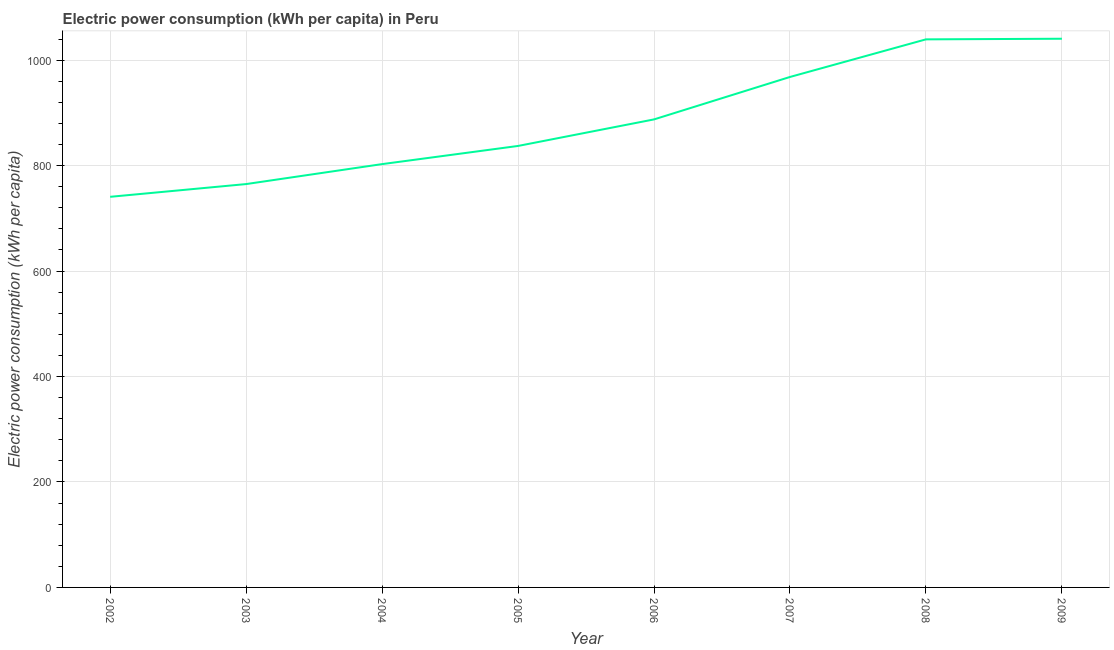What is the electric power consumption in 2005?
Your response must be concise. 837.29. Across all years, what is the maximum electric power consumption?
Your response must be concise. 1040.63. Across all years, what is the minimum electric power consumption?
Your answer should be very brief. 740.82. In which year was the electric power consumption minimum?
Your answer should be very brief. 2002. What is the sum of the electric power consumption?
Provide a succinct answer. 7081.78. What is the difference between the electric power consumption in 2003 and 2004?
Offer a very short reply. -37.85. What is the average electric power consumption per year?
Your answer should be very brief. 885.22. What is the median electric power consumption?
Provide a short and direct response. 862.46. In how many years, is the electric power consumption greater than 920 kWh per capita?
Provide a short and direct response. 3. What is the ratio of the electric power consumption in 2005 to that in 2006?
Your response must be concise. 0.94. Is the difference between the electric power consumption in 2003 and 2005 greater than the difference between any two years?
Offer a terse response. No. What is the difference between the highest and the second highest electric power consumption?
Provide a succinct answer. 1.18. What is the difference between the highest and the lowest electric power consumption?
Give a very brief answer. 299.81. Does the graph contain any zero values?
Give a very brief answer. No. What is the title of the graph?
Your answer should be very brief. Electric power consumption (kWh per capita) in Peru. What is the label or title of the X-axis?
Your response must be concise. Year. What is the label or title of the Y-axis?
Provide a succinct answer. Electric power consumption (kWh per capita). What is the Electric power consumption (kWh per capita) of 2002?
Ensure brevity in your answer.  740.82. What is the Electric power consumption (kWh per capita) in 2003?
Keep it short and to the point. 764.99. What is the Electric power consumption (kWh per capita) in 2004?
Ensure brevity in your answer.  802.84. What is the Electric power consumption (kWh per capita) in 2005?
Your answer should be compact. 837.29. What is the Electric power consumption (kWh per capita) of 2006?
Keep it short and to the point. 887.62. What is the Electric power consumption (kWh per capita) in 2007?
Provide a short and direct response. 968.13. What is the Electric power consumption (kWh per capita) of 2008?
Your answer should be compact. 1039.45. What is the Electric power consumption (kWh per capita) of 2009?
Offer a terse response. 1040.63. What is the difference between the Electric power consumption (kWh per capita) in 2002 and 2003?
Your response must be concise. -24.16. What is the difference between the Electric power consumption (kWh per capita) in 2002 and 2004?
Your answer should be compact. -62.02. What is the difference between the Electric power consumption (kWh per capita) in 2002 and 2005?
Ensure brevity in your answer.  -96.47. What is the difference between the Electric power consumption (kWh per capita) in 2002 and 2006?
Make the answer very short. -146.8. What is the difference between the Electric power consumption (kWh per capita) in 2002 and 2007?
Offer a very short reply. -227.3. What is the difference between the Electric power consumption (kWh per capita) in 2002 and 2008?
Ensure brevity in your answer.  -298.63. What is the difference between the Electric power consumption (kWh per capita) in 2002 and 2009?
Give a very brief answer. -299.81. What is the difference between the Electric power consumption (kWh per capita) in 2003 and 2004?
Your response must be concise. -37.85. What is the difference between the Electric power consumption (kWh per capita) in 2003 and 2005?
Keep it short and to the point. -72.31. What is the difference between the Electric power consumption (kWh per capita) in 2003 and 2006?
Your response must be concise. -122.64. What is the difference between the Electric power consumption (kWh per capita) in 2003 and 2007?
Provide a short and direct response. -203.14. What is the difference between the Electric power consumption (kWh per capita) in 2003 and 2008?
Provide a short and direct response. -274.46. What is the difference between the Electric power consumption (kWh per capita) in 2003 and 2009?
Provide a succinct answer. -275.65. What is the difference between the Electric power consumption (kWh per capita) in 2004 and 2005?
Offer a very short reply. -34.45. What is the difference between the Electric power consumption (kWh per capita) in 2004 and 2006?
Give a very brief answer. -84.78. What is the difference between the Electric power consumption (kWh per capita) in 2004 and 2007?
Your response must be concise. -165.29. What is the difference between the Electric power consumption (kWh per capita) in 2004 and 2008?
Offer a very short reply. -236.61. What is the difference between the Electric power consumption (kWh per capita) in 2004 and 2009?
Your answer should be compact. -237.79. What is the difference between the Electric power consumption (kWh per capita) in 2005 and 2006?
Your answer should be compact. -50.33. What is the difference between the Electric power consumption (kWh per capita) in 2005 and 2007?
Offer a very short reply. -130.83. What is the difference between the Electric power consumption (kWh per capita) in 2005 and 2008?
Offer a very short reply. -202.16. What is the difference between the Electric power consumption (kWh per capita) in 2005 and 2009?
Give a very brief answer. -203.34. What is the difference between the Electric power consumption (kWh per capita) in 2006 and 2007?
Offer a terse response. -80.51. What is the difference between the Electric power consumption (kWh per capita) in 2006 and 2008?
Ensure brevity in your answer.  -151.83. What is the difference between the Electric power consumption (kWh per capita) in 2006 and 2009?
Provide a succinct answer. -153.01. What is the difference between the Electric power consumption (kWh per capita) in 2007 and 2008?
Offer a terse response. -71.32. What is the difference between the Electric power consumption (kWh per capita) in 2007 and 2009?
Keep it short and to the point. -72.51. What is the difference between the Electric power consumption (kWh per capita) in 2008 and 2009?
Provide a succinct answer. -1.18. What is the ratio of the Electric power consumption (kWh per capita) in 2002 to that in 2003?
Ensure brevity in your answer.  0.97. What is the ratio of the Electric power consumption (kWh per capita) in 2002 to that in 2004?
Provide a succinct answer. 0.92. What is the ratio of the Electric power consumption (kWh per capita) in 2002 to that in 2005?
Your response must be concise. 0.89. What is the ratio of the Electric power consumption (kWh per capita) in 2002 to that in 2006?
Provide a short and direct response. 0.83. What is the ratio of the Electric power consumption (kWh per capita) in 2002 to that in 2007?
Provide a succinct answer. 0.77. What is the ratio of the Electric power consumption (kWh per capita) in 2002 to that in 2008?
Offer a very short reply. 0.71. What is the ratio of the Electric power consumption (kWh per capita) in 2002 to that in 2009?
Your response must be concise. 0.71. What is the ratio of the Electric power consumption (kWh per capita) in 2003 to that in 2004?
Offer a very short reply. 0.95. What is the ratio of the Electric power consumption (kWh per capita) in 2003 to that in 2005?
Make the answer very short. 0.91. What is the ratio of the Electric power consumption (kWh per capita) in 2003 to that in 2006?
Your answer should be compact. 0.86. What is the ratio of the Electric power consumption (kWh per capita) in 2003 to that in 2007?
Your answer should be very brief. 0.79. What is the ratio of the Electric power consumption (kWh per capita) in 2003 to that in 2008?
Your answer should be compact. 0.74. What is the ratio of the Electric power consumption (kWh per capita) in 2003 to that in 2009?
Offer a very short reply. 0.73. What is the ratio of the Electric power consumption (kWh per capita) in 2004 to that in 2006?
Your answer should be very brief. 0.9. What is the ratio of the Electric power consumption (kWh per capita) in 2004 to that in 2007?
Your response must be concise. 0.83. What is the ratio of the Electric power consumption (kWh per capita) in 2004 to that in 2008?
Make the answer very short. 0.77. What is the ratio of the Electric power consumption (kWh per capita) in 2004 to that in 2009?
Offer a terse response. 0.77. What is the ratio of the Electric power consumption (kWh per capita) in 2005 to that in 2006?
Make the answer very short. 0.94. What is the ratio of the Electric power consumption (kWh per capita) in 2005 to that in 2007?
Make the answer very short. 0.86. What is the ratio of the Electric power consumption (kWh per capita) in 2005 to that in 2008?
Provide a short and direct response. 0.81. What is the ratio of the Electric power consumption (kWh per capita) in 2005 to that in 2009?
Offer a very short reply. 0.81. What is the ratio of the Electric power consumption (kWh per capita) in 2006 to that in 2007?
Your answer should be very brief. 0.92. What is the ratio of the Electric power consumption (kWh per capita) in 2006 to that in 2008?
Give a very brief answer. 0.85. What is the ratio of the Electric power consumption (kWh per capita) in 2006 to that in 2009?
Ensure brevity in your answer.  0.85. 